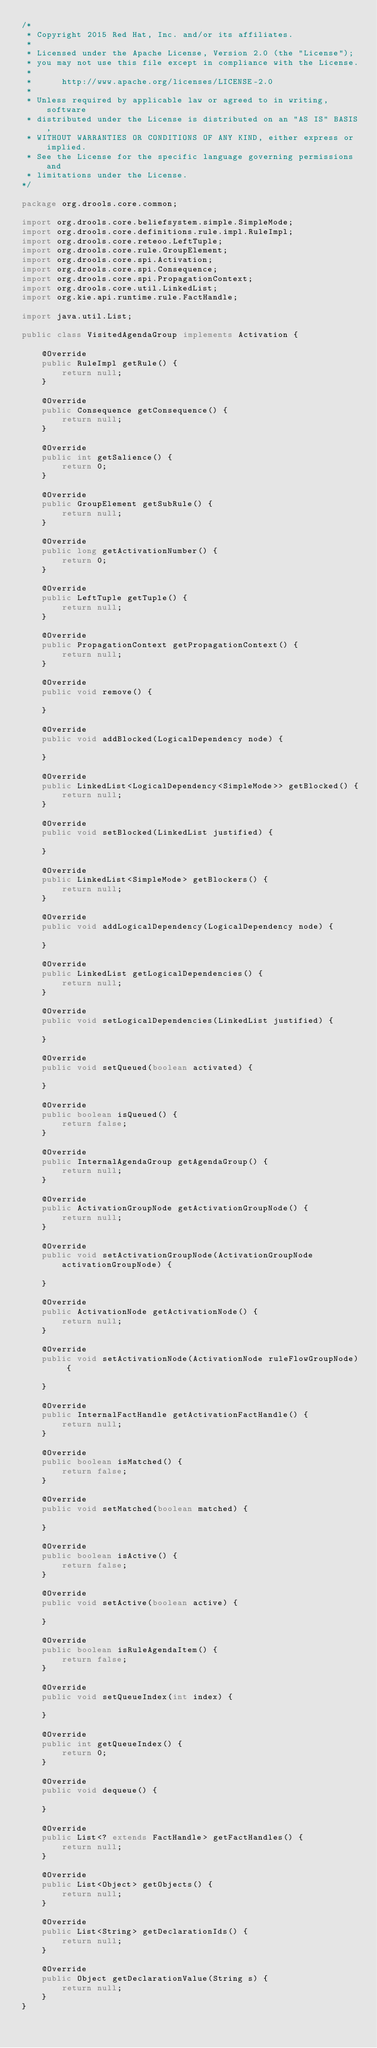<code> <loc_0><loc_0><loc_500><loc_500><_Java_>/*
 * Copyright 2015 Red Hat, Inc. and/or its affiliates.
 *
 * Licensed under the Apache License, Version 2.0 (the "License");
 * you may not use this file except in compliance with the License.
 * 
 *      http://www.apache.org/licenses/LICENSE-2.0
 *
 * Unless required by applicable law or agreed to in writing, software
 * distributed under the License is distributed on an "AS IS" BASIS,
 * WITHOUT WARRANTIES OR CONDITIONS OF ANY KIND, either express or implied.
 * See the License for the specific language governing permissions and
 * limitations under the License.
*/

package org.drools.core.common;

import org.drools.core.beliefsystem.simple.SimpleMode;
import org.drools.core.definitions.rule.impl.RuleImpl;
import org.drools.core.reteoo.LeftTuple;
import org.drools.core.rule.GroupElement;
import org.drools.core.spi.Activation;
import org.drools.core.spi.Consequence;
import org.drools.core.spi.PropagationContext;
import org.drools.core.util.LinkedList;
import org.kie.api.runtime.rule.FactHandle;

import java.util.List;

public class VisitedAgendaGroup implements Activation {

    @Override
    public RuleImpl getRule() {
        return null;
    }

    @Override
    public Consequence getConsequence() {
        return null;
    }

    @Override
    public int getSalience() {
        return 0;
    }

    @Override
    public GroupElement getSubRule() {
        return null;
    }

    @Override
    public long getActivationNumber() {
        return 0;
    }

    @Override
    public LeftTuple getTuple() {
        return null;
    }

    @Override
    public PropagationContext getPropagationContext() {
        return null;
    }

    @Override
    public void remove() {

    }

    @Override
    public void addBlocked(LogicalDependency node) {

    }

    @Override
    public LinkedList<LogicalDependency<SimpleMode>> getBlocked() {
        return null;
    }

    @Override
    public void setBlocked(LinkedList justified) {

    }

    @Override
    public LinkedList<SimpleMode> getBlockers() {
        return null;
    }

    @Override
    public void addLogicalDependency(LogicalDependency node) {

    }

    @Override
    public LinkedList getLogicalDependencies() {
        return null;
    }

    @Override
    public void setLogicalDependencies(LinkedList justified) {

    }

    @Override
    public void setQueued(boolean activated) {

    }

    @Override
    public boolean isQueued() {
        return false;
    }

    @Override
    public InternalAgendaGroup getAgendaGroup() {
        return null;
    }

    @Override
    public ActivationGroupNode getActivationGroupNode() {
        return null;
    }

    @Override
    public void setActivationGroupNode(ActivationGroupNode activationGroupNode) {

    }

    @Override
    public ActivationNode getActivationNode() {
        return null;
    }

    @Override
    public void setActivationNode(ActivationNode ruleFlowGroupNode) {

    }

    @Override
    public InternalFactHandle getActivationFactHandle() {
        return null;
    }

    @Override
    public boolean isMatched() {
        return false;
    }

    @Override
    public void setMatched(boolean matched) {

    }

    @Override
    public boolean isActive() {
        return false;
    }

    @Override
    public void setActive(boolean active) {

    }

    @Override
    public boolean isRuleAgendaItem() {
        return false;
    }

    @Override
    public void setQueueIndex(int index) {

    }

    @Override
    public int getQueueIndex() {
        return 0;
    }

    @Override
    public void dequeue() {

    }

    @Override
    public List<? extends FactHandle> getFactHandles() {
        return null;
    }

    @Override
    public List<Object> getObjects() {
        return null;
    }

    @Override
    public List<String> getDeclarationIds() {
        return null;
    }

    @Override
    public Object getDeclarationValue(String s) {
        return null;
    }
}
</code> 